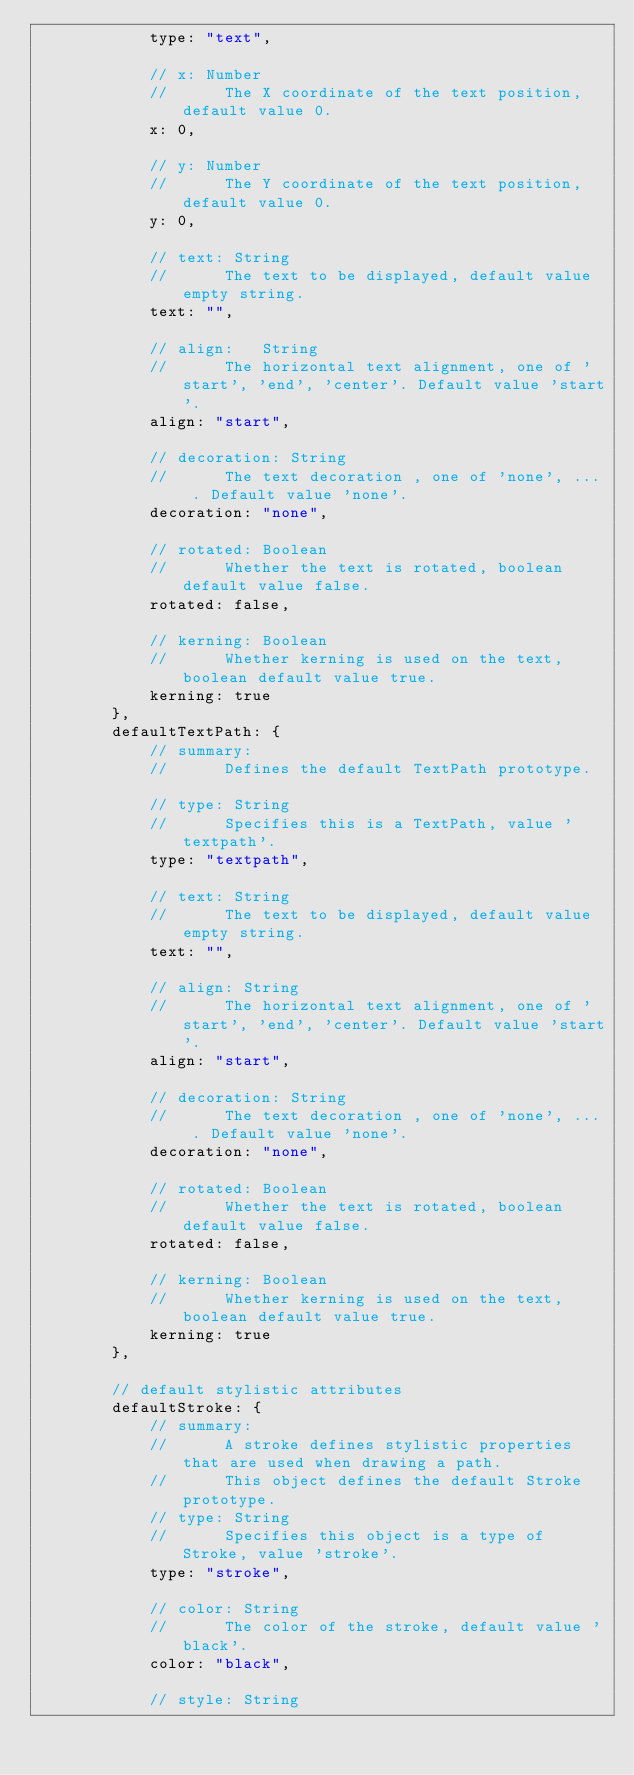<code> <loc_0><loc_0><loc_500><loc_500><_JavaScript_>			type: "text",

			// x: Number
			//		The X coordinate of the text position, default value 0.
			x: 0,

			// y: Number
			//		The Y coordinate of the text position, default value 0.
			y: 0,

			// text: String
			//		The text to be displayed, default value empty string.
			text: "",

			// align:	String
			//		The horizontal text alignment, one of 'start', 'end', 'center'. Default value 'start'.
			align: "start",

			// decoration: String
			//		The text decoration , one of 'none', ... . Default value 'none'.
			decoration: "none",

			// rotated: Boolean
			//		Whether the text is rotated, boolean default value false.
			rotated: false,

			// kerning: Boolean
			//		Whether kerning is used on the text, boolean default value true.
			kerning: true
		},
		defaultTextPath: {
			// summary:
			//		Defines the default TextPath prototype.

			// type: String
			//		Specifies this is a TextPath, value 'textpath'.
			type: "textpath",

			// text: String
			//		The text to be displayed, default value empty string.
			text: "",

			// align: String
			//		The horizontal text alignment, one of 'start', 'end', 'center'. Default value 'start'.
			align: "start",

			// decoration: String
			//		The text decoration , one of 'none', ... . Default value 'none'.
			decoration: "none",

			// rotated: Boolean
			//		Whether the text is rotated, boolean default value false.
			rotated: false,

			// kerning: Boolean
			//		Whether kerning is used on the text, boolean default value true.
			kerning: true
		},

		// default stylistic attributes
		defaultStroke: {
			// summary:
			//		A stroke defines stylistic properties that are used when drawing a path.
			//		This object defines the default Stroke prototype.
			// type: String
			//		Specifies this object is a type of Stroke, value 'stroke'.
			type: "stroke",

			// color: String
			//		The color of the stroke, default value 'black'.
			color: "black",

			// style: String</code> 